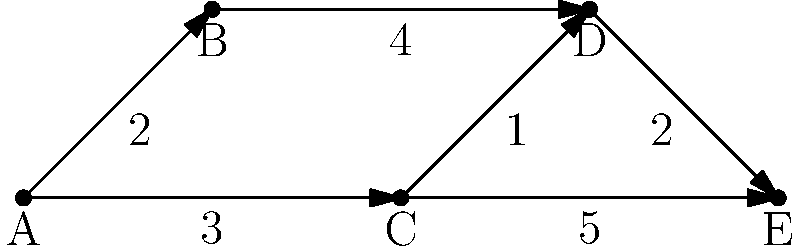Given the directed graph representing the supply chain for skateboard components, where vertices represent suppliers and edges represent shipping routes with associated costs, what is the minimum cost to ship components from supplier A to supplier E? To find the minimum cost path from supplier A to supplier E, we'll use Dijkstra's algorithm:

1. Initialize distances: A(0), B(∞), C(∞), D(∞), E(∞)
2. Start from A:
   - Update B: min(∞, 0+2) = 2
   - Update C: min(∞, 0+3) = 3
3. Select B (lowest unvisited):
   - Update D: min(∞, 2+4) = 6
4. Select C:
   - Update D: min(6, 3+1) = 4
   - Update E: min(∞, 3+5) = 8
5. Select D:
   - Update E: min(8, 4+2) = 6
6. Select E (destination reached)

The minimum cost path is A → C → D → E with a total cost of 6.
Answer: 6 